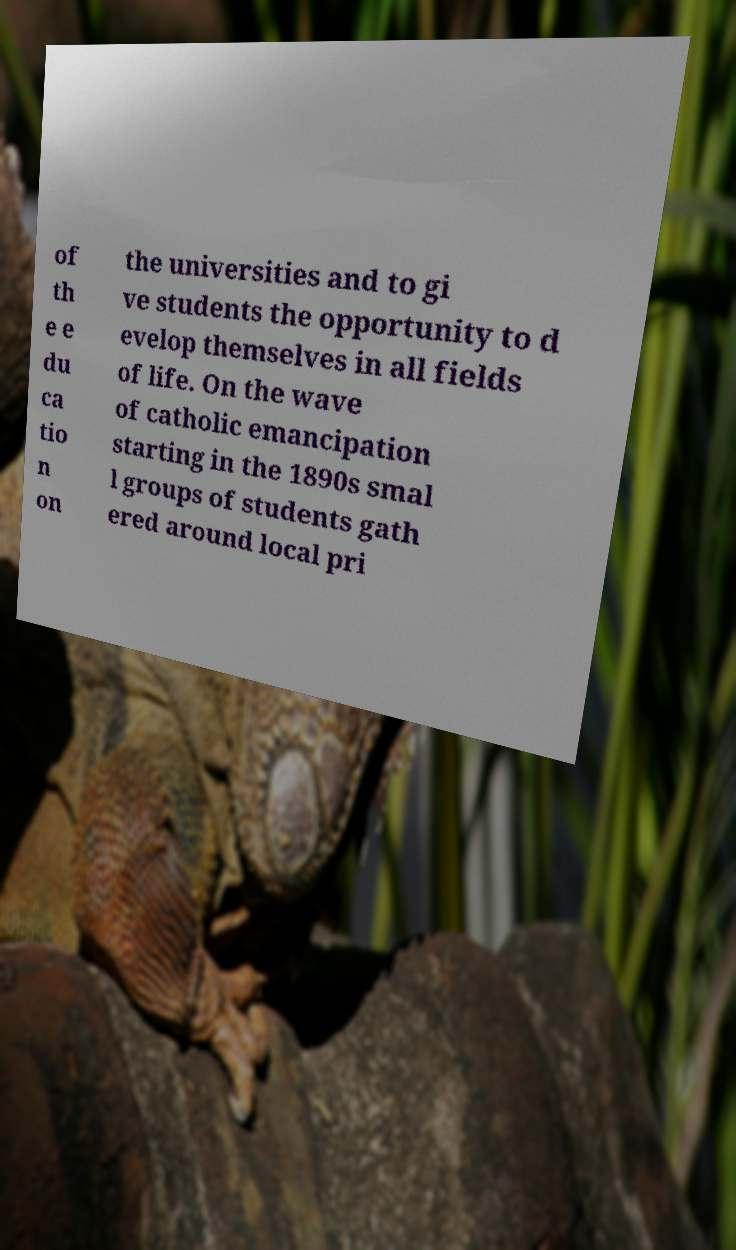For documentation purposes, I need the text within this image transcribed. Could you provide that? of th e e du ca tio n on the universities and to gi ve students the opportunity to d evelop themselves in all fields of life. On the wave of catholic emancipation starting in the 1890s smal l groups of students gath ered around local pri 